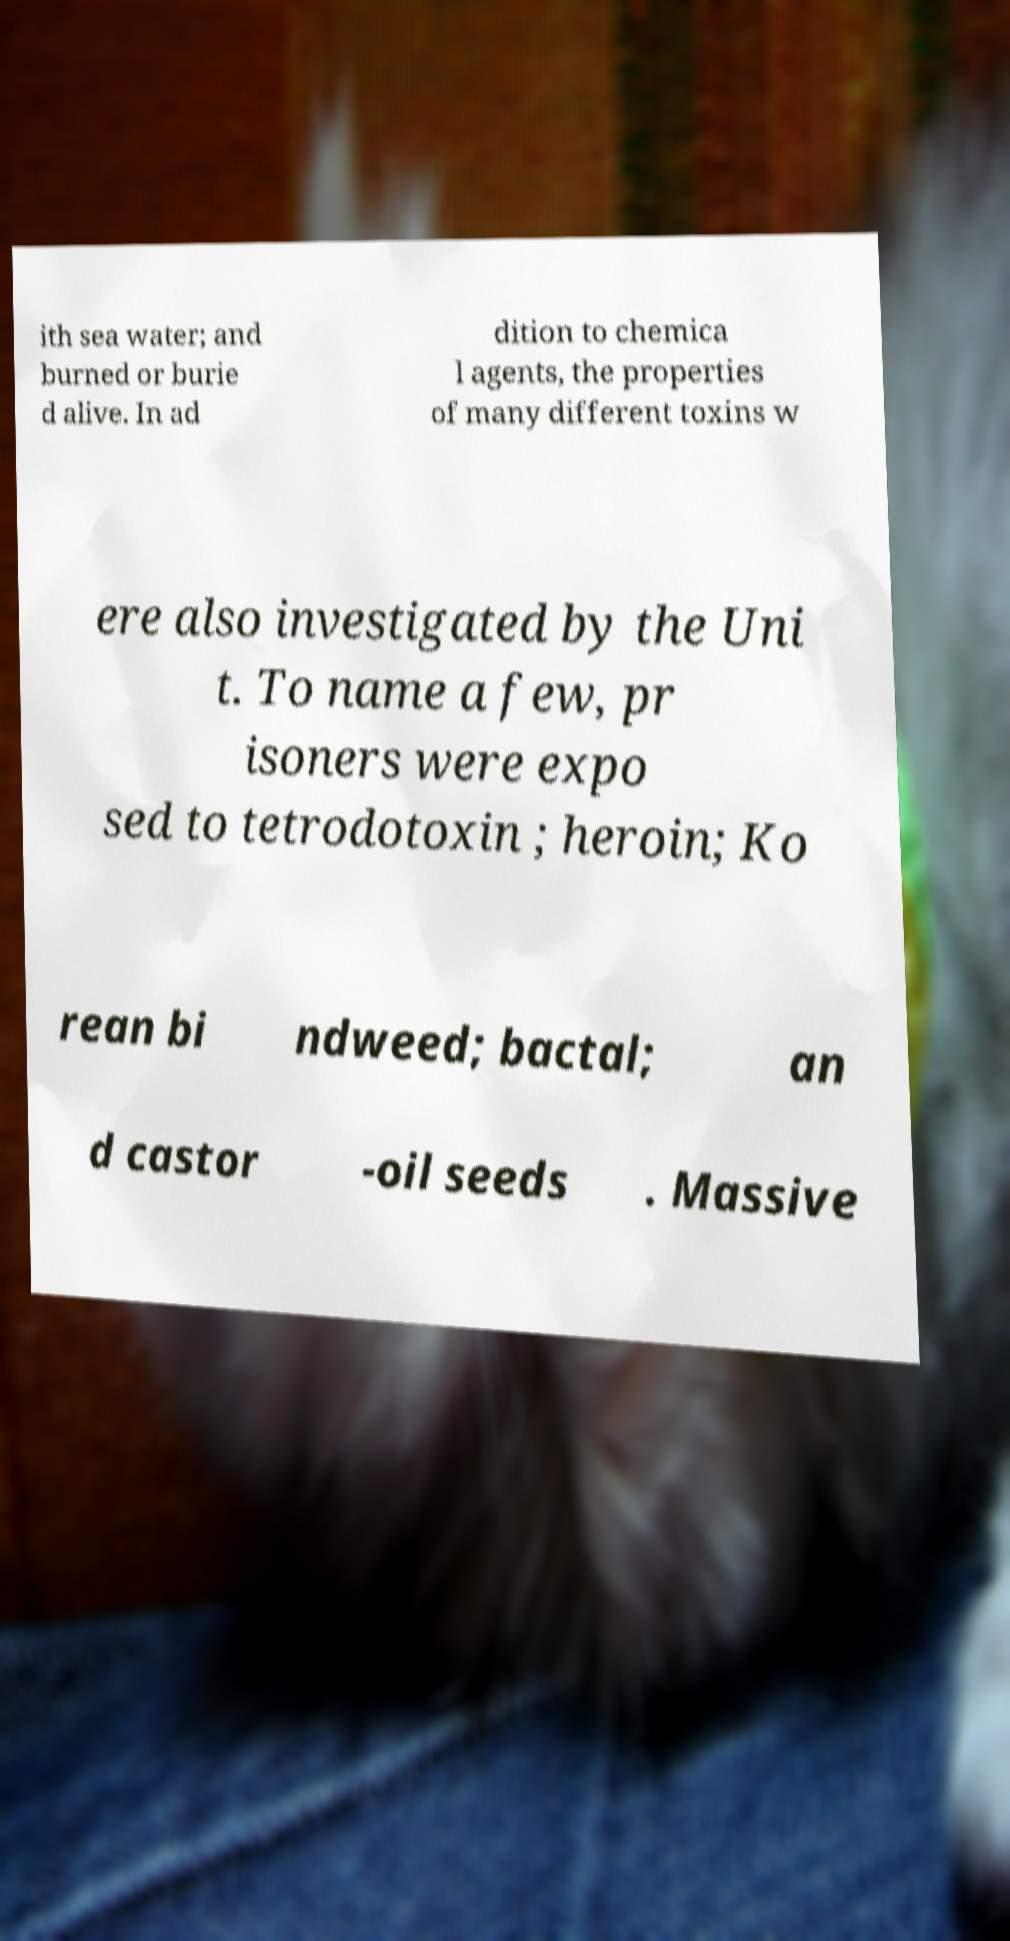Please identify and transcribe the text found in this image. ith sea water; and burned or burie d alive. In ad dition to chemica l agents, the properties of many different toxins w ere also investigated by the Uni t. To name a few, pr isoners were expo sed to tetrodotoxin ; heroin; Ko rean bi ndweed; bactal; an d castor -oil seeds . Massive 